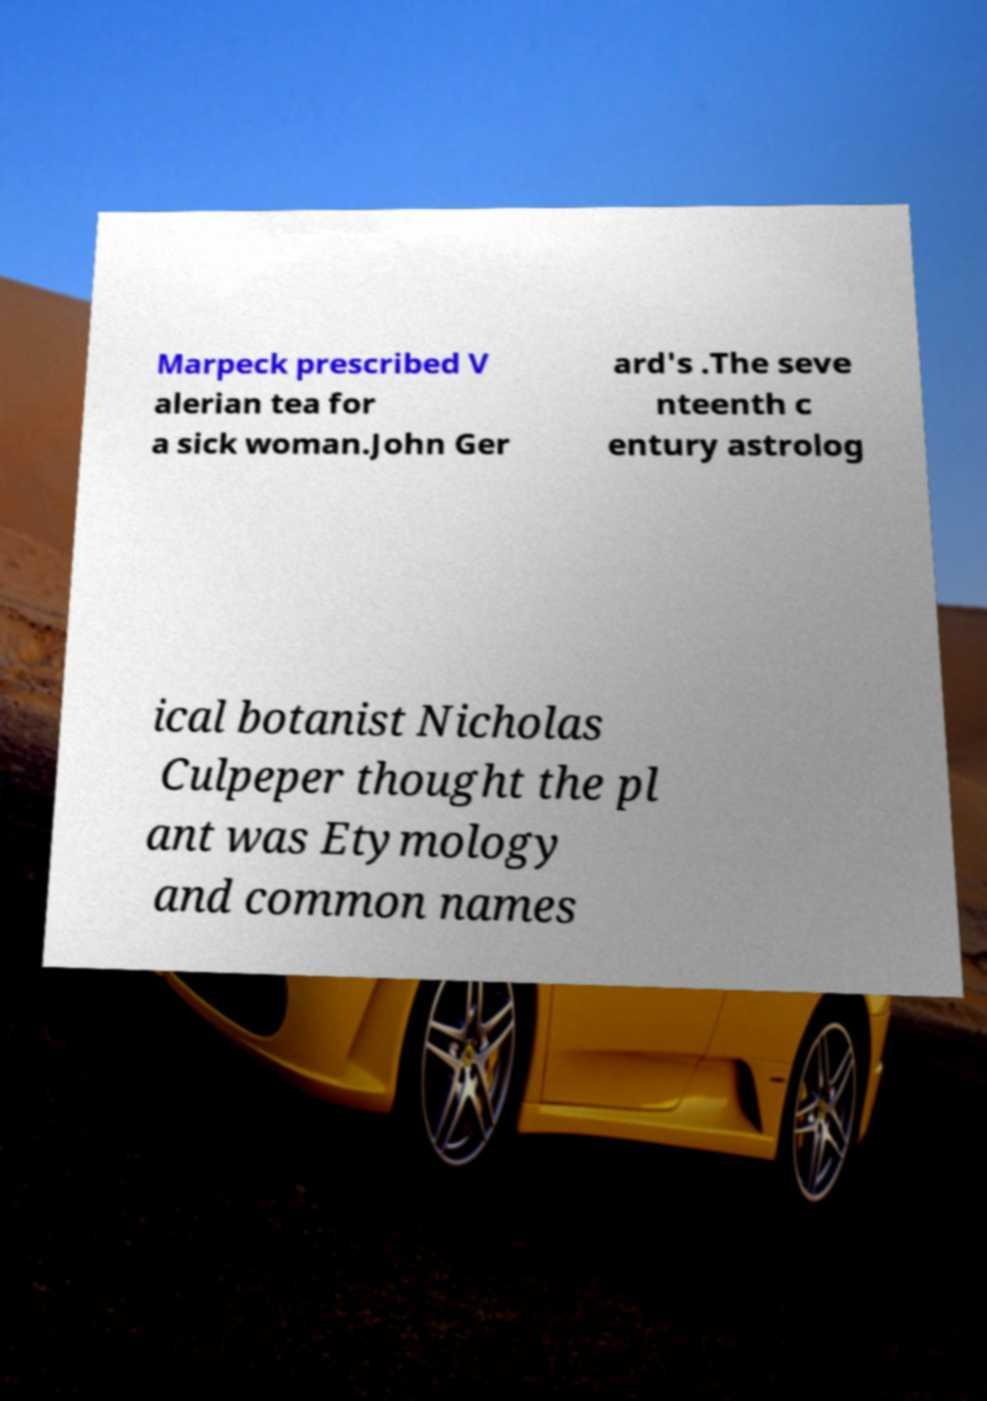I need the written content from this picture converted into text. Can you do that? Marpeck prescribed V alerian tea for a sick woman.John Ger ard's .The seve nteenth c entury astrolog ical botanist Nicholas Culpeper thought the pl ant was Etymology and common names 